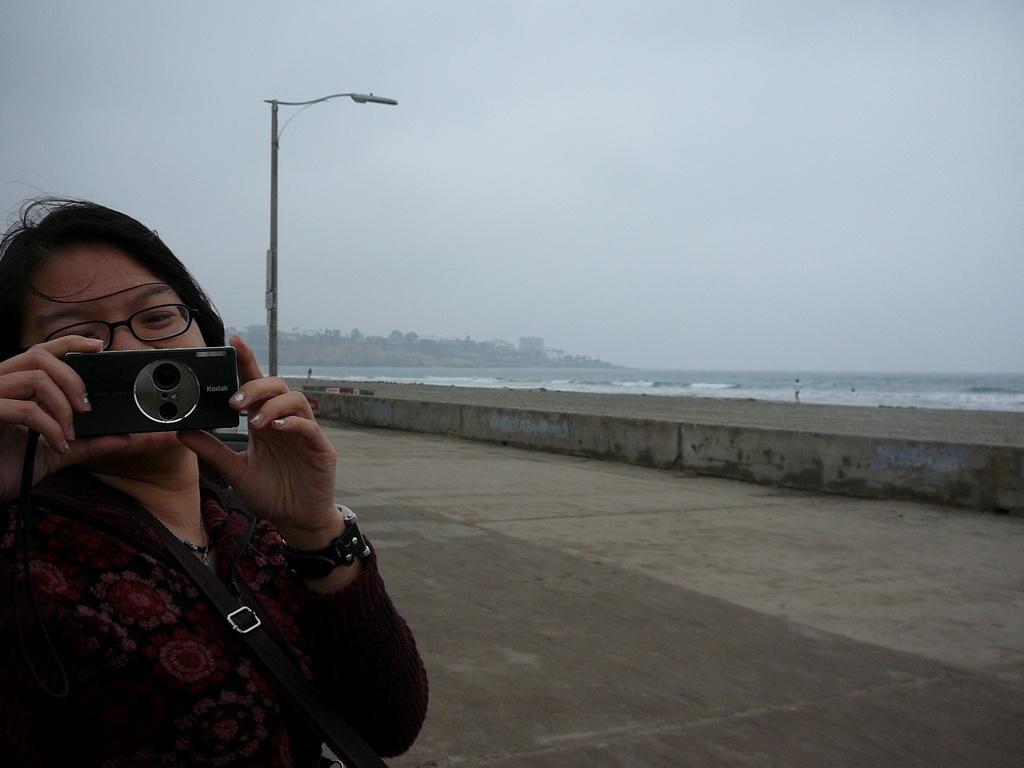Could you give a brief overview of what you see in this image? As we can see in the image there is a clear sky, water, street lamp and a woman holding camera. 